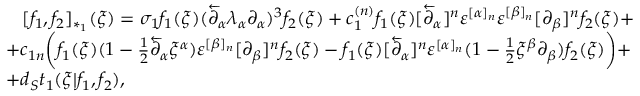Convert formula to latex. <formula><loc_0><loc_0><loc_500><loc_500>\begin{array} { l } { { \, [ f _ { 1 } , f _ { 2 } ] _ { * _ { 1 } } ( \xi ) = \sigma _ { 1 } f _ { 1 } ( \xi ) ( \overleftarrow { \partial } _ { \alpha } \lambda _ { \alpha } \partial _ { \alpha } ) ^ { 3 } f _ { 2 } ( \xi ) + c _ { 1 } ^ { ( n ) } f _ { 1 } ( \xi ) [ \overleftarrow { \partial } _ { \alpha } ] ^ { n } \varepsilon ^ { [ \alpha ] _ { n } } \varepsilon ^ { [ \beta ] _ { n } } [ \partial _ { \beta } ] ^ { n } f _ { 2 } ( \xi ) + } } \\ { { + c _ { 1 n } \left ( f _ { 1 } ( \xi ) ( 1 - { \frac { 1 } { 2 } } \overleftarrow { \partial } _ { \alpha } \xi ^ { \alpha } ) \varepsilon ^ { [ \beta ] _ { n } } [ \partial _ { \beta } ] ^ { n } f _ { 2 } ( \xi ) - f _ { 1 } ( \xi ) [ \overleftarrow { \partial } _ { \alpha } ] ^ { n } \varepsilon ^ { [ \alpha ] _ { n } } ( 1 - { \frac { 1 } { 2 } } \xi ^ { \beta } \partial _ { \beta } ) f _ { 2 } ( \xi ) \right ) + } } \\ { { + d _ { S } t _ { 1 } ( \xi | f _ { 1 } , f _ { 2 } ) , } } \end{array}</formula> 